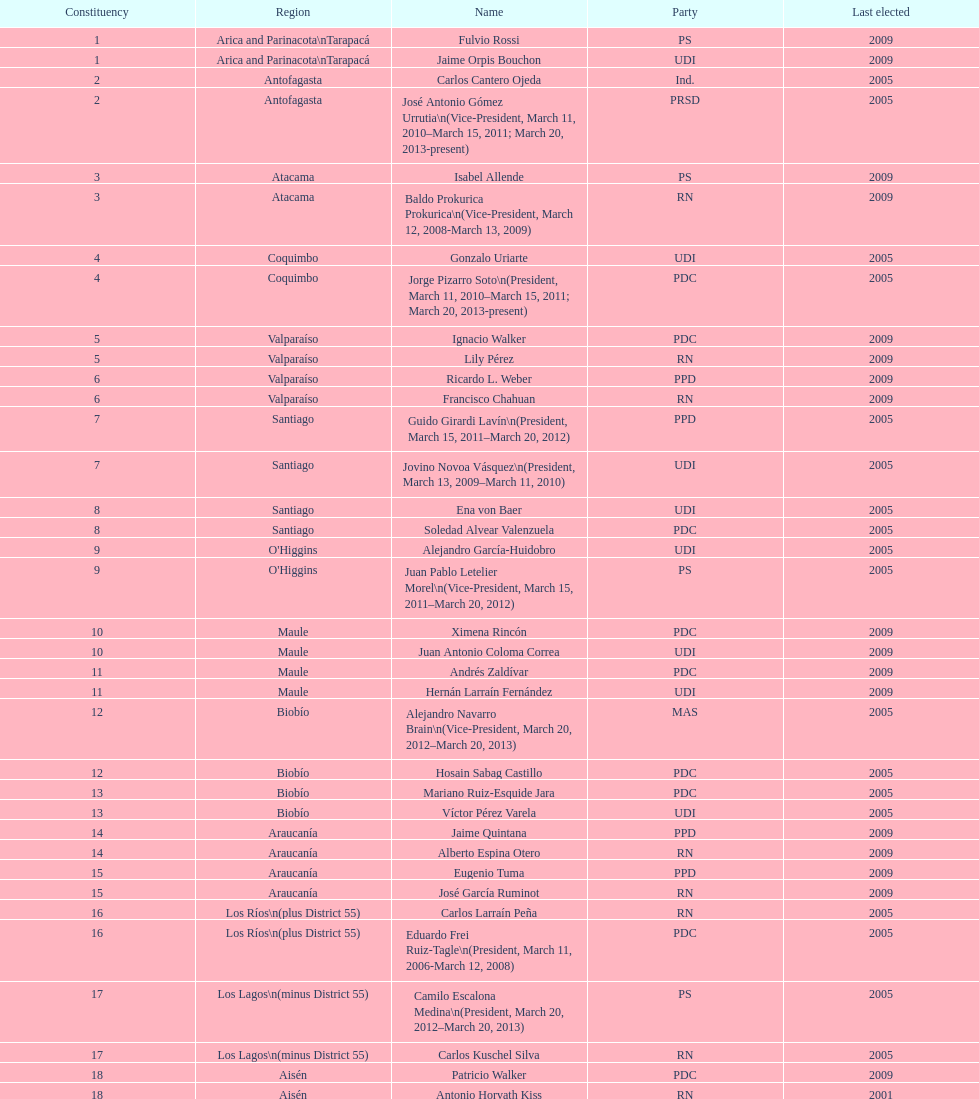To which party was jaime quintana affiliated? PPD. 